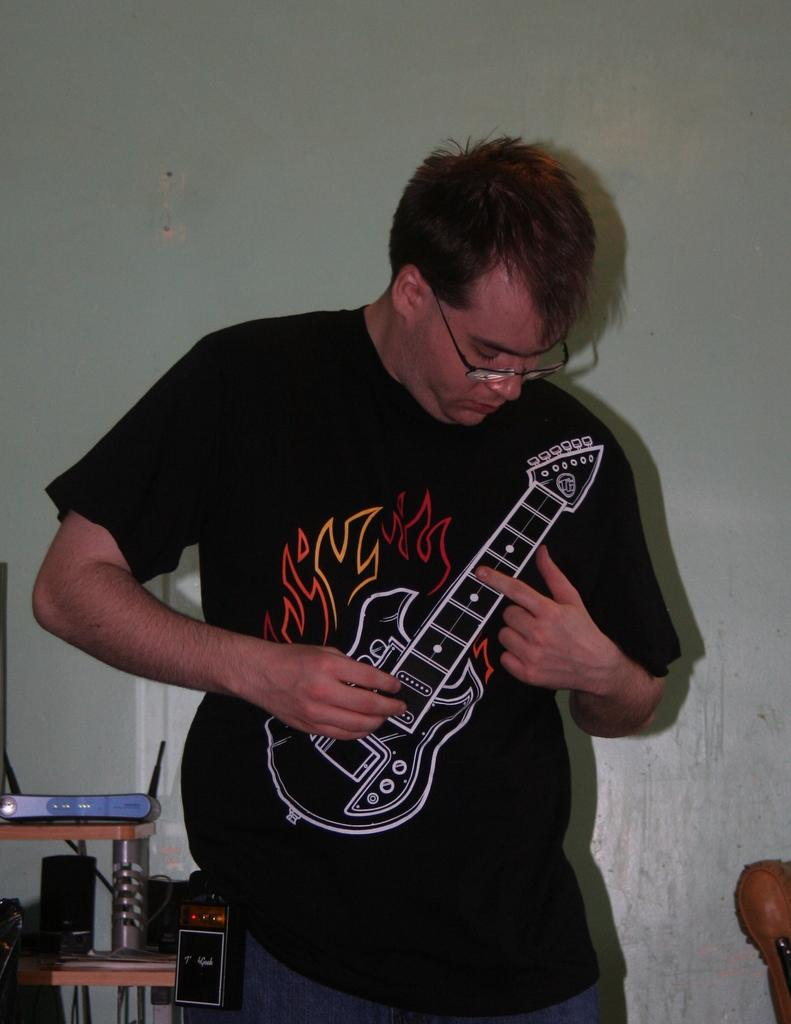What is the main subject in the center of the image? There is a man standing in the center of the image. What can be seen on the left side of the image? There are speakers and a table on the left side of the image. What is visible in the background of the image? There is a wall in the background of the image. What shape is the spring that is visible in the image? There is no spring present in the image. 